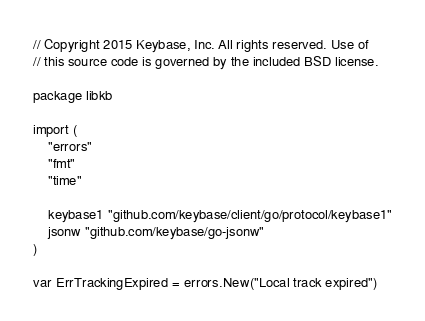Convert code to text. <code><loc_0><loc_0><loc_500><loc_500><_Go_>// Copyright 2015 Keybase, Inc. All rights reserved. Use of
// this source code is governed by the included BSD license.

package libkb

import (
	"errors"
	"fmt"
	"time"

	keybase1 "github.com/keybase/client/go/protocol/keybase1"
	jsonw "github.com/keybase/go-jsonw"
)

var ErrTrackingExpired = errors.New("Local track expired")
</code> 